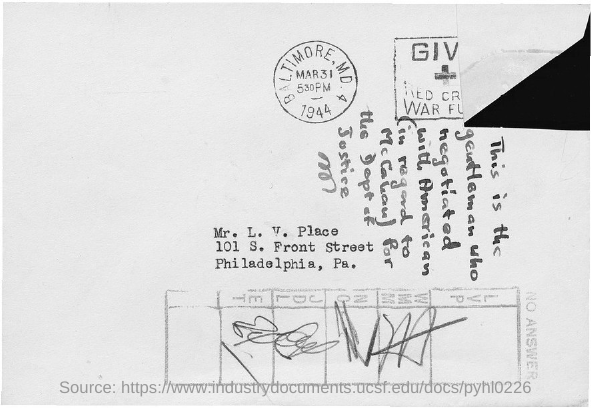Identify some key points in this picture. The person named in the address is Mr. L. V. Place. 